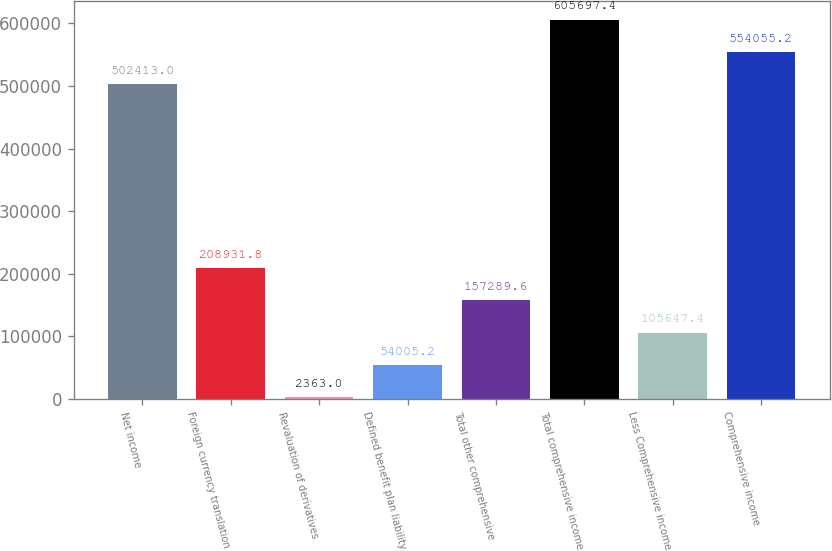<chart> <loc_0><loc_0><loc_500><loc_500><bar_chart><fcel>Net income<fcel>Foreign currency translation<fcel>Revaluation of derivatives<fcel>Defined benefit plan liability<fcel>Total other comprehensive<fcel>Total comprehensive income<fcel>Less Comprehensive income<fcel>Comprehensive income<nl><fcel>502413<fcel>208932<fcel>2363<fcel>54005.2<fcel>157290<fcel>605697<fcel>105647<fcel>554055<nl></chart> 